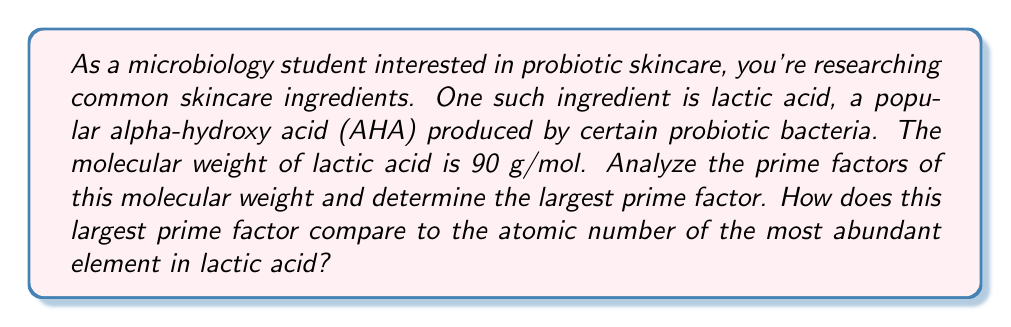Provide a solution to this math problem. Let's approach this step-by-step:

1) First, we need to find the prime factors of 90 (the molecular weight of lactic acid).

   To do this, we'll divide 90 by the smallest prime number that divides into it evenly, and repeat this process until we can't go further.

   $90 = 2 \times 45$
   $45 = 3 \times 15$
   $15 = 3 \times 5$

   Therefore, $90 = 2 \times 3 \times 3 \times 5$

2) The prime factorization of 90 is:

   $90 = 2^1 \times 3^2 \times 5^1$

3) The prime factors are 2, 3, and 5. The largest among these is 5.

4) Now, let's consider the composition of lactic acid. Its molecular formula is $C_3H_6O_3$.

5) The most abundant element in lactic acid is hydrogen (H), with 6 atoms per molecule.

6) The atomic number of hydrogen is 1.

7) Comparing the largest prime factor (5) to the atomic number of hydrogen (1):

   $5 > 1$

Therefore, the largest prime factor of lactic acid's molecular weight is greater than the atomic number of its most abundant element.
Answer: The largest prime factor of lactic acid's molecular weight is 5, which is greater than 1, the atomic number of hydrogen (the most abundant element in lactic acid). 